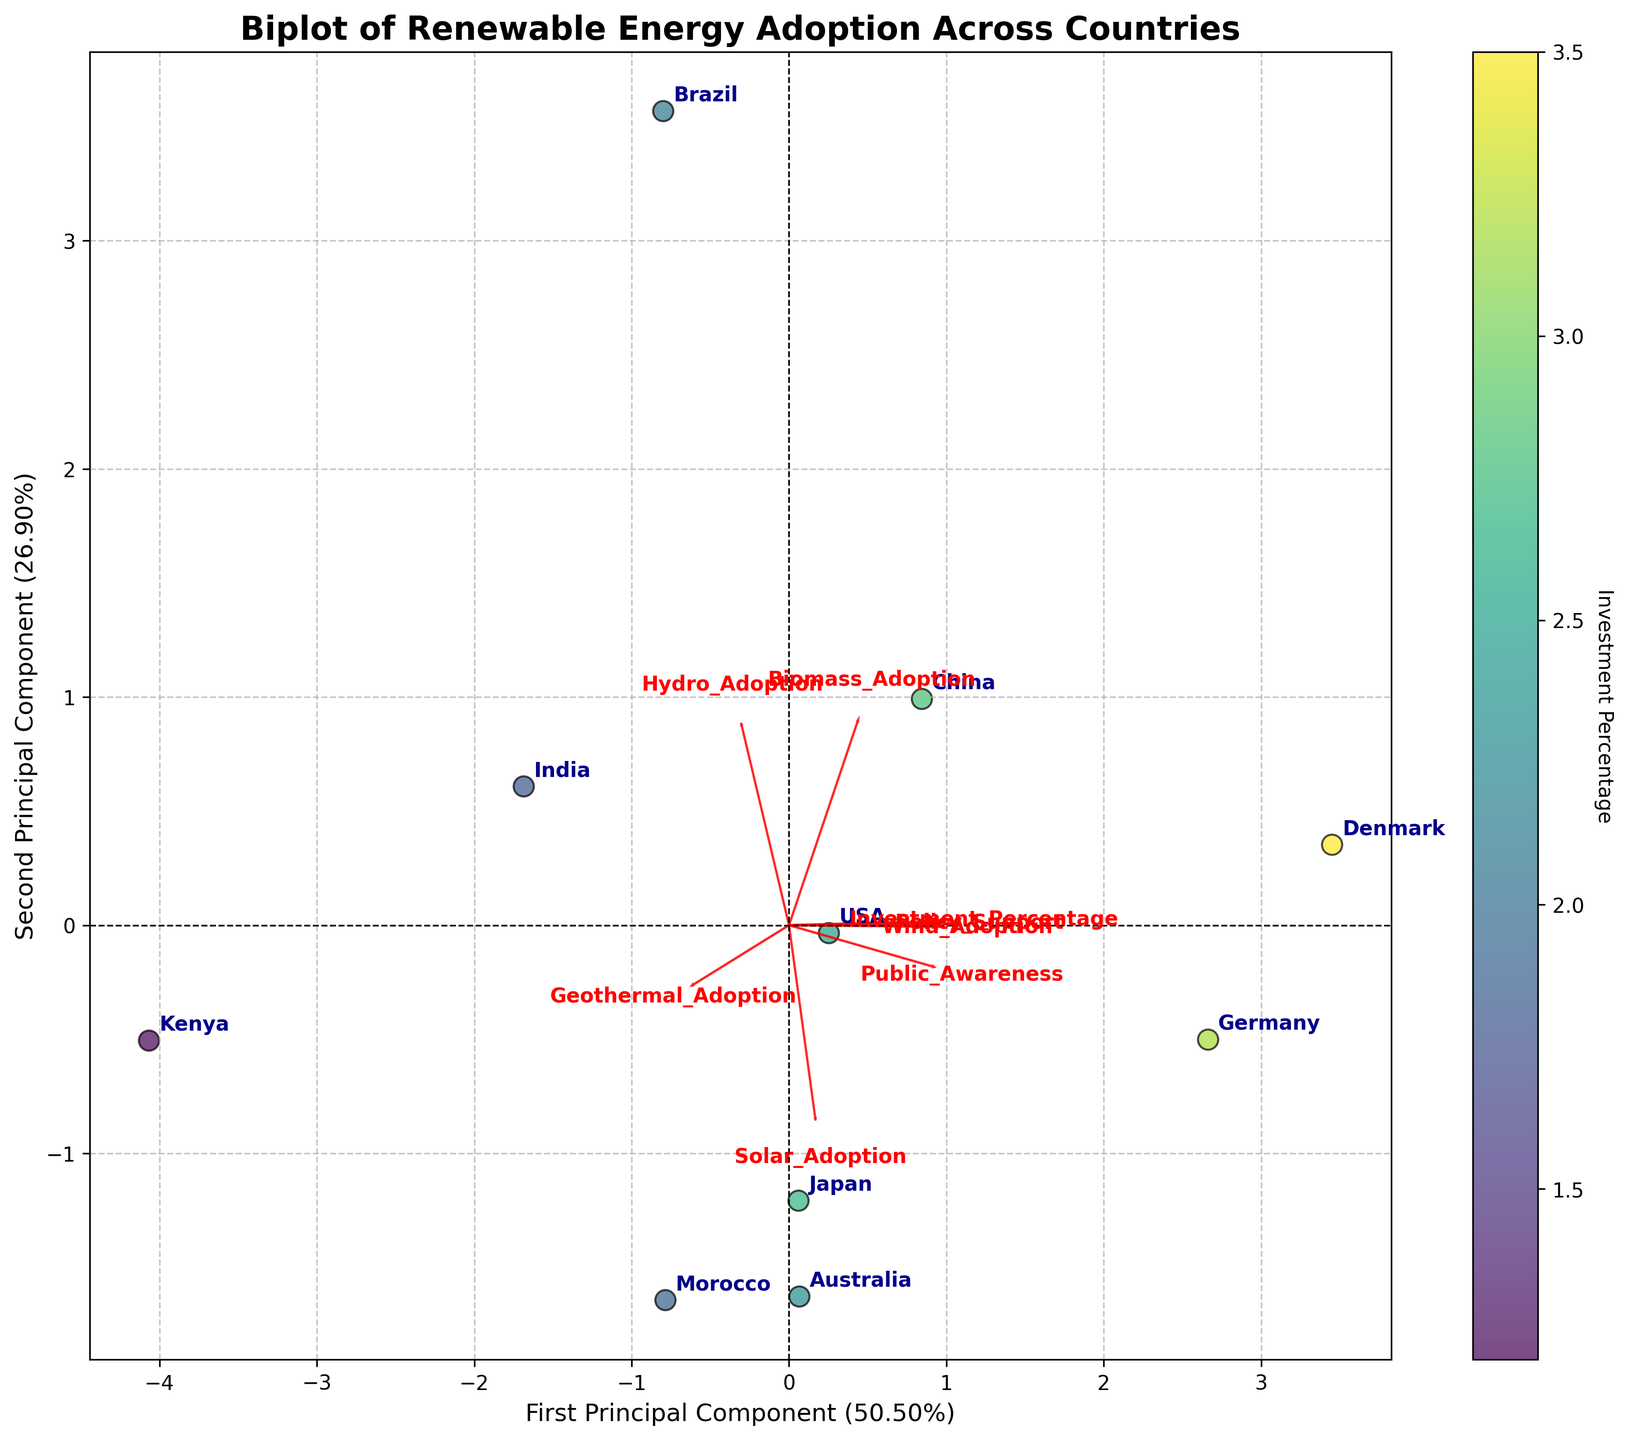What is the title of the biplot? The title of the biplot is written at the top of the figure in bold. It reads: "Biplot of Renewable Energy Adoption Across Countries."
Answer: Biplot of Renewable Energy Adoption Across Countries Which country has the highest Investment Percentage? The color of the scatter points represents the Investment Percentage, with darker colors indicating higher values. Denmark has the darkest color, implying the highest Investment Percentage.
Answer: Denmark What is the x-axis labeled? The x-axis label is found horizontally along the bottom of the plot. It reads: "First Principal Component." The percentage of explained variance is also specified.
Answer: First Principal Component Which countries are clustered near the first principal component's negative side? By observing the positions of the countries relative to the x-axis, Germany, USA, China, and Japan are near the negative side of the first principal component.
Answer: Germany, USA, China, Japan Which feature is most closely aligned with the first principal component (x-axis)? Features are represented by red arrows. The arrow with the largest horizontal component shows the feature most aligned with the first principal component. "Policy_Support" has the longest arrow along the x-axis.
Answer: Policy_Support Which two countries are closest to each other on the plot? By visually inspecting the distance between points, Germany and China are plotted closely together, indicating their similarity based on the principal components analysis.
Answer: Germany, China Does Solar_Adoption contribute more to the first or second principal component? Solar_Adoption is indicated by a red arrow. Its direction and length along the axes show contributions. The arrow for Solar_Adoption points more along the x-axis than the y-axis, suggesting a greater contribution to the first principal component.
Answer: First Principal Component Which feature is least correlated with the second principal component (y-axis)? The shortest arrow in the vertical direction indicates the least correlation with the second principal component. "Investment_Percentage" is nearly horizontal, suggesting minimal vertical component.
Answer: Investment_Percentage How much variance is explained by the first two principal components combined? The x-axis and y-axis labels indicate the explained variance for each component. Summing these provides the total explained variance. From the labels: "First Principal Component (explains approximately 40%)" and "Second Principal Component (explains approximately 30%)", thus combined variance is 40% + 30%.
Answer: 70% Which country's public awareness is highest according to the biplot? The plot has annotations showing country names and the color intensity indicates higher public awareness. Japan, with one of the boldest annotations and highest placement, implies it has high public awareness.
Answer: Japan 